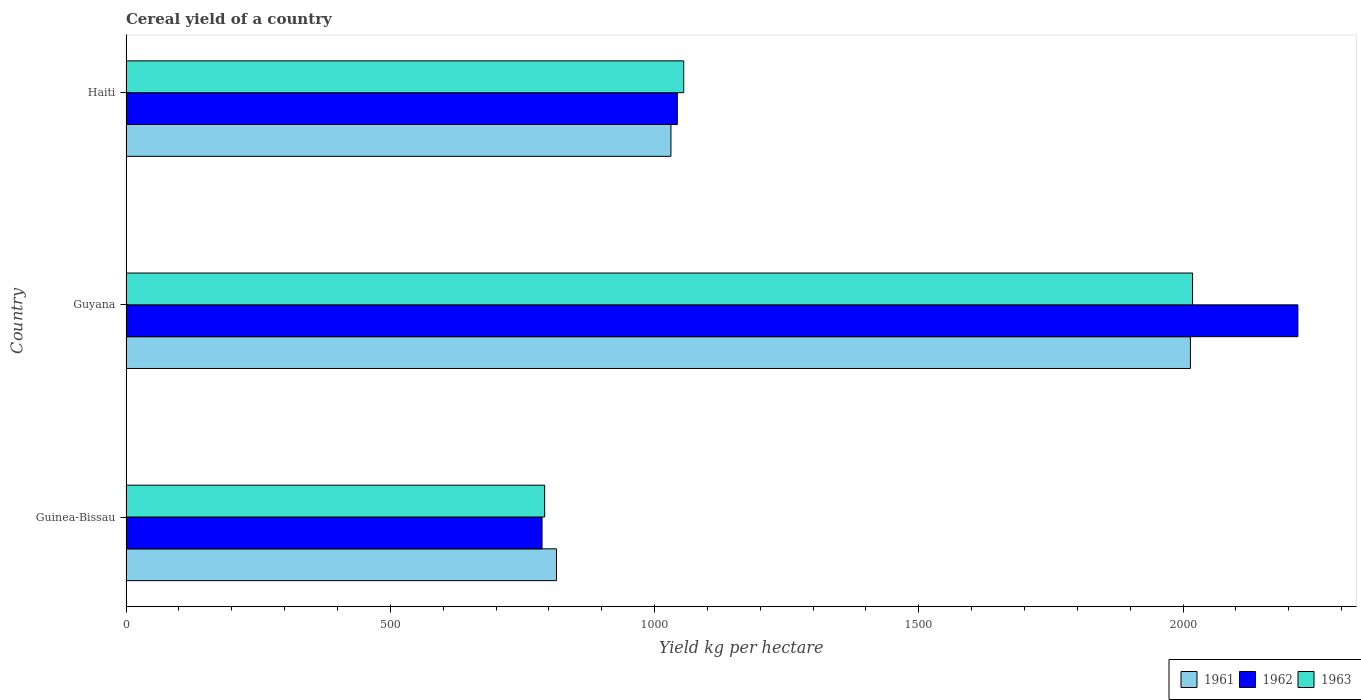How many groups of bars are there?
Offer a very short reply. 3. Are the number of bars per tick equal to the number of legend labels?
Your answer should be compact. Yes. Are the number of bars on each tick of the Y-axis equal?
Your answer should be compact. Yes. What is the label of the 3rd group of bars from the top?
Ensure brevity in your answer.  Guinea-Bissau. In how many cases, is the number of bars for a given country not equal to the number of legend labels?
Keep it short and to the point. 0. What is the total cereal yield in 1961 in Guinea-Bissau?
Make the answer very short. 814.43. Across all countries, what is the maximum total cereal yield in 1963?
Provide a succinct answer. 2017.87. Across all countries, what is the minimum total cereal yield in 1962?
Ensure brevity in your answer.  787.13. In which country was the total cereal yield in 1961 maximum?
Offer a terse response. Guyana. In which country was the total cereal yield in 1963 minimum?
Make the answer very short. Guinea-Bissau. What is the total total cereal yield in 1961 in the graph?
Offer a very short reply. 3859.19. What is the difference between the total cereal yield in 1963 in Guyana and that in Haiti?
Provide a succinct answer. 962.68. What is the difference between the total cereal yield in 1963 in Guyana and the total cereal yield in 1962 in Guinea-Bissau?
Your answer should be very brief. 1230.74. What is the average total cereal yield in 1961 per country?
Provide a succinct answer. 1286.4. What is the difference between the total cereal yield in 1961 and total cereal yield in 1962 in Guinea-Bissau?
Keep it short and to the point. 27.3. In how many countries, is the total cereal yield in 1963 greater than 1600 kg per hectare?
Your answer should be compact. 1. What is the ratio of the total cereal yield in 1962 in Guinea-Bissau to that in Guyana?
Keep it short and to the point. 0.36. Is the total cereal yield in 1962 in Guyana less than that in Haiti?
Keep it short and to the point. No. Is the difference between the total cereal yield in 1961 in Guyana and Haiti greater than the difference between the total cereal yield in 1962 in Guyana and Haiti?
Offer a terse response. No. What is the difference between the highest and the second highest total cereal yield in 1962?
Keep it short and to the point. 1174.1. What is the difference between the highest and the lowest total cereal yield in 1961?
Provide a succinct answer. 1199.35. What does the 1st bar from the bottom in Guinea-Bissau represents?
Your answer should be compact. 1961. How many bars are there?
Provide a short and direct response. 9. Are all the bars in the graph horizontal?
Your answer should be compact. Yes. How many countries are there in the graph?
Your answer should be very brief. 3. Does the graph contain grids?
Your response must be concise. No. How are the legend labels stacked?
Ensure brevity in your answer.  Horizontal. What is the title of the graph?
Provide a succinct answer. Cereal yield of a country. Does "1973" appear as one of the legend labels in the graph?
Your answer should be compact. No. What is the label or title of the X-axis?
Offer a very short reply. Yield kg per hectare. What is the label or title of the Y-axis?
Make the answer very short. Country. What is the Yield kg per hectare in 1961 in Guinea-Bissau?
Keep it short and to the point. 814.43. What is the Yield kg per hectare of 1962 in Guinea-Bissau?
Keep it short and to the point. 787.13. What is the Yield kg per hectare in 1963 in Guinea-Bissau?
Your answer should be compact. 792.08. What is the Yield kg per hectare of 1961 in Guyana?
Your answer should be compact. 2013.78. What is the Yield kg per hectare of 1962 in Guyana?
Give a very brief answer. 2217.15. What is the Yield kg per hectare in 1963 in Guyana?
Offer a very short reply. 2017.87. What is the Yield kg per hectare of 1961 in Haiti?
Your answer should be very brief. 1030.97. What is the Yield kg per hectare of 1962 in Haiti?
Provide a succinct answer. 1043.05. What is the Yield kg per hectare in 1963 in Haiti?
Give a very brief answer. 1055.19. Across all countries, what is the maximum Yield kg per hectare of 1961?
Provide a succinct answer. 2013.78. Across all countries, what is the maximum Yield kg per hectare in 1962?
Offer a terse response. 2217.15. Across all countries, what is the maximum Yield kg per hectare in 1963?
Give a very brief answer. 2017.87. Across all countries, what is the minimum Yield kg per hectare of 1961?
Offer a terse response. 814.43. Across all countries, what is the minimum Yield kg per hectare in 1962?
Provide a succinct answer. 787.13. Across all countries, what is the minimum Yield kg per hectare of 1963?
Your answer should be compact. 792.08. What is the total Yield kg per hectare of 1961 in the graph?
Make the answer very short. 3859.19. What is the total Yield kg per hectare in 1962 in the graph?
Provide a succinct answer. 4047.32. What is the total Yield kg per hectare of 1963 in the graph?
Offer a very short reply. 3865.14. What is the difference between the Yield kg per hectare in 1961 in Guinea-Bissau and that in Guyana?
Provide a succinct answer. -1199.35. What is the difference between the Yield kg per hectare of 1962 in Guinea-Bissau and that in Guyana?
Provide a succinct answer. -1430.02. What is the difference between the Yield kg per hectare in 1963 in Guinea-Bissau and that in Guyana?
Keep it short and to the point. -1225.79. What is the difference between the Yield kg per hectare of 1961 in Guinea-Bissau and that in Haiti?
Make the answer very short. -216.54. What is the difference between the Yield kg per hectare in 1962 in Guinea-Bissau and that in Haiti?
Give a very brief answer. -255.92. What is the difference between the Yield kg per hectare in 1963 in Guinea-Bissau and that in Haiti?
Ensure brevity in your answer.  -263.11. What is the difference between the Yield kg per hectare in 1961 in Guyana and that in Haiti?
Give a very brief answer. 982.81. What is the difference between the Yield kg per hectare of 1962 in Guyana and that in Haiti?
Keep it short and to the point. 1174.1. What is the difference between the Yield kg per hectare in 1963 in Guyana and that in Haiti?
Offer a terse response. 962.68. What is the difference between the Yield kg per hectare of 1961 in Guinea-Bissau and the Yield kg per hectare of 1962 in Guyana?
Give a very brief answer. -1402.72. What is the difference between the Yield kg per hectare in 1961 in Guinea-Bissau and the Yield kg per hectare in 1963 in Guyana?
Ensure brevity in your answer.  -1203.44. What is the difference between the Yield kg per hectare in 1962 in Guinea-Bissau and the Yield kg per hectare in 1963 in Guyana?
Your answer should be compact. -1230.74. What is the difference between the Yield kg per hectare of 1961 in Guinea-Bissau and the Yield kg per hectare of 1962 in Haiti?
Ensure brevity in your answer.  -228.61. What is the difference between the Yield kg per hectare in 1961 in Guinea-Bissau and the Yield kg per hectare in 1963 in Haiti?
Offer a terse response. -240.75. What is the difference between the Yield kg per hectare in 1962 in Guinea-Bissau and the Yield kg per hectare in 1963 in Haiti?
Your answer should be very brief. -268.06. What is the difference between the Yield kg per hectare in 1961 in Guyana and the Yield kg per hectare in 1962 in Haiti?
Offer a very short reply. 970.74. What is the difference between the Yield kg per hectare in 1961 in Guyana and the Yield kg per hectare in 1963 in Haiti?
Your answer should be compact. 958.59. What is the difference between the Yield kg per hectare of 1962 in Guyana and the Yield kg per hectare of 1963 in Haiti?
Provide a short and direct response. 1161.96. What is the average Yield kg per hectare of 1961 per country?
Keep it short and to the point. 1286.4. What is the average Yield kg per hectare of 1962 per country?
Your answer should be compact. 1349.11. What is the average Yield kg per hectare of 1963 per country?
Provide a short and direct response. 1288.38. What is the difference between the Yield kg per hectare of 1961 and Yield kg per hectare of 1962 in Guinea-Bissau?
Offer a very short reply. 27.3. What is the difference between the Yield kg per hectare of 1961 and Yield kg per hectare of 1963 in Guinea-Bissau?
Make the answer very short. 22.35. What is the difference between the Yield kg per hectare of 1962 and Yield kg per hectare of 1963 in Guinea-Bissau?
Provide a short and direct response. -4.95. What is the difference between the Yield kg per hectare of 1961 and Yield kg per hectare of 1962 in Guyana?
Your answer should be very brief. -203.37. What is the difference between the Yield kg per hectare in 1961 and Yield kg per hectare in 1963 in Guyana?
Ensure brevity in your answer.  -4.09. What is the difference between the Yield kg per hectare of 1962 and Yield kg per hectare of 1963 in Guyana?
Keep it short and to the point. 199.28. What is the difference between the Yield kg per hectare of 1961 and Yield kg per hectare of 1962 in Haiti?
Your answer should be very brief. -12.07. What is the difference between the Yield kg per hectare in 1961 and Yield kg per hectare in 1963 in Haiti?
Offer a terse response. -24.21. What is the difference between the Yield kg per hectare in 1962 and Yield kg per hectare in 1963 in Haiti?
Keep it short and to the point. -12.14. What is the ratio of the Yield kg per hectare of 1961 in Guinea-Bissau to that in Guyana?
Offer a terse response. 0.4. What is the ratio of the Yield kg per hectare in 1962 in Guinea-Bissau to that in Guyana?
Give a very brief answer. 0.35. What is the ratio of the Yield kg per hectare in 1963 in Guinea-Bissau to that in Guyana?
Offer a terse response. 0.39. What is the ratio of the Yield kg per hectare of 1961 in Guinea-Bissau to that in Haiti?
Your answer should be compact. 0.79. What is the ratio of the Yield kg per hectare in 1962 in Guinea-Bissau to that in Haiti?
Offer a terse response. 0.75. What is the ratio of the Yield kg per hectare of 1963 in Guinea-Bissau to that in Haiti?
Ensure brevity in your answer.  0.75. What is the ratio of the Yield kg per hectare in 1961 in Guyana to that in Haiti?
Offer a terse response. 1.95. What is the ratio of the Yield kg per hectare of 1962 in Guyana to that in Haiti?
Ensure brevity in your answer.  2.13. What is the ratio of the Yield kg per hectare in 1963 in Guyana to that in Haiti?
Offer a very short reply. 1.91. What is the difference between the highest and the second highest Yield kg per hectare of 1961?
Your response must be concise. 982.81. What is the difference between the highest and the second highest Yield kg per hectare of 1962?
Provide a short and direct response. 1174.1. What is the difference between the highest and the second highest Yield kg per hectare in 1963?
Your answer should be compact. 962.68. What is the difference between the highest and the lowest Yield kg per hectare of 1961?
Provide a short and direct response. 1199.35. What is the difference between the highest and the lowest Yield kg per hectare of 1962?
Offer a terse response. 1430.02. What is the difference between the highest and the lowest Yield kg per hectare of 1963?
Your answer should be very brief. 1225.79. 